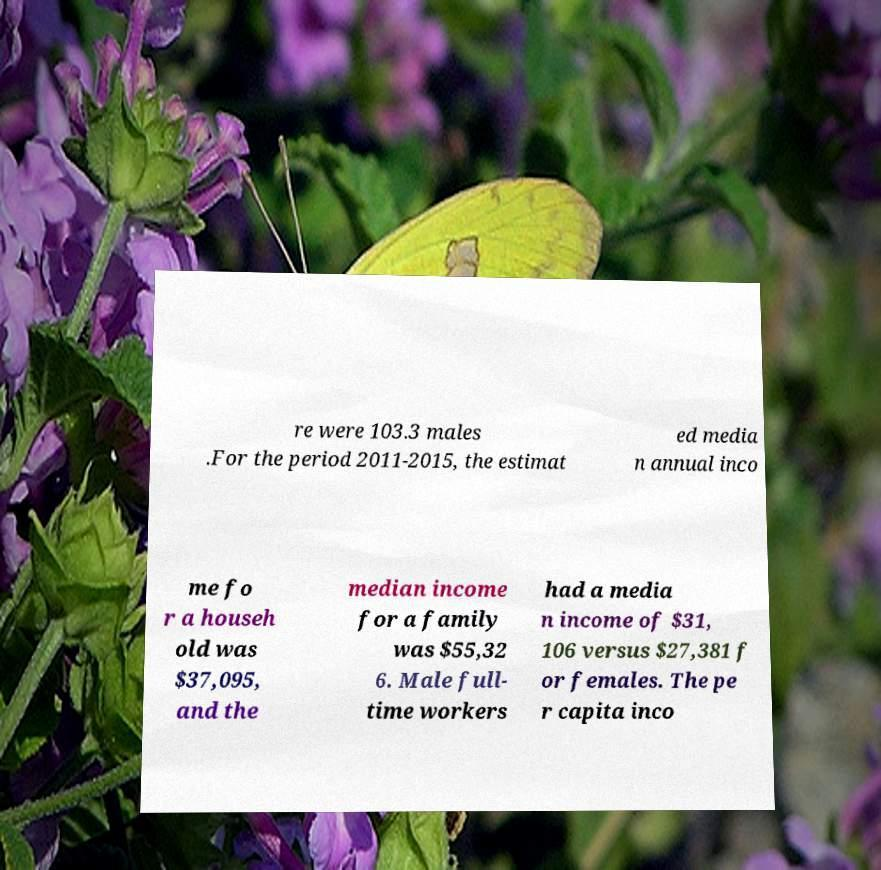Please read and relay the text visible in this image. What does it say? re were 103.3 males .For the period 2011-2015, the estimat ed media n annual inco me fo r a househ old was $37,095, and the median income for a family was $55,32 6. Male full- time workers had a media n income of $31, 106 versus $27,381 f or females. The pe r capita inco 